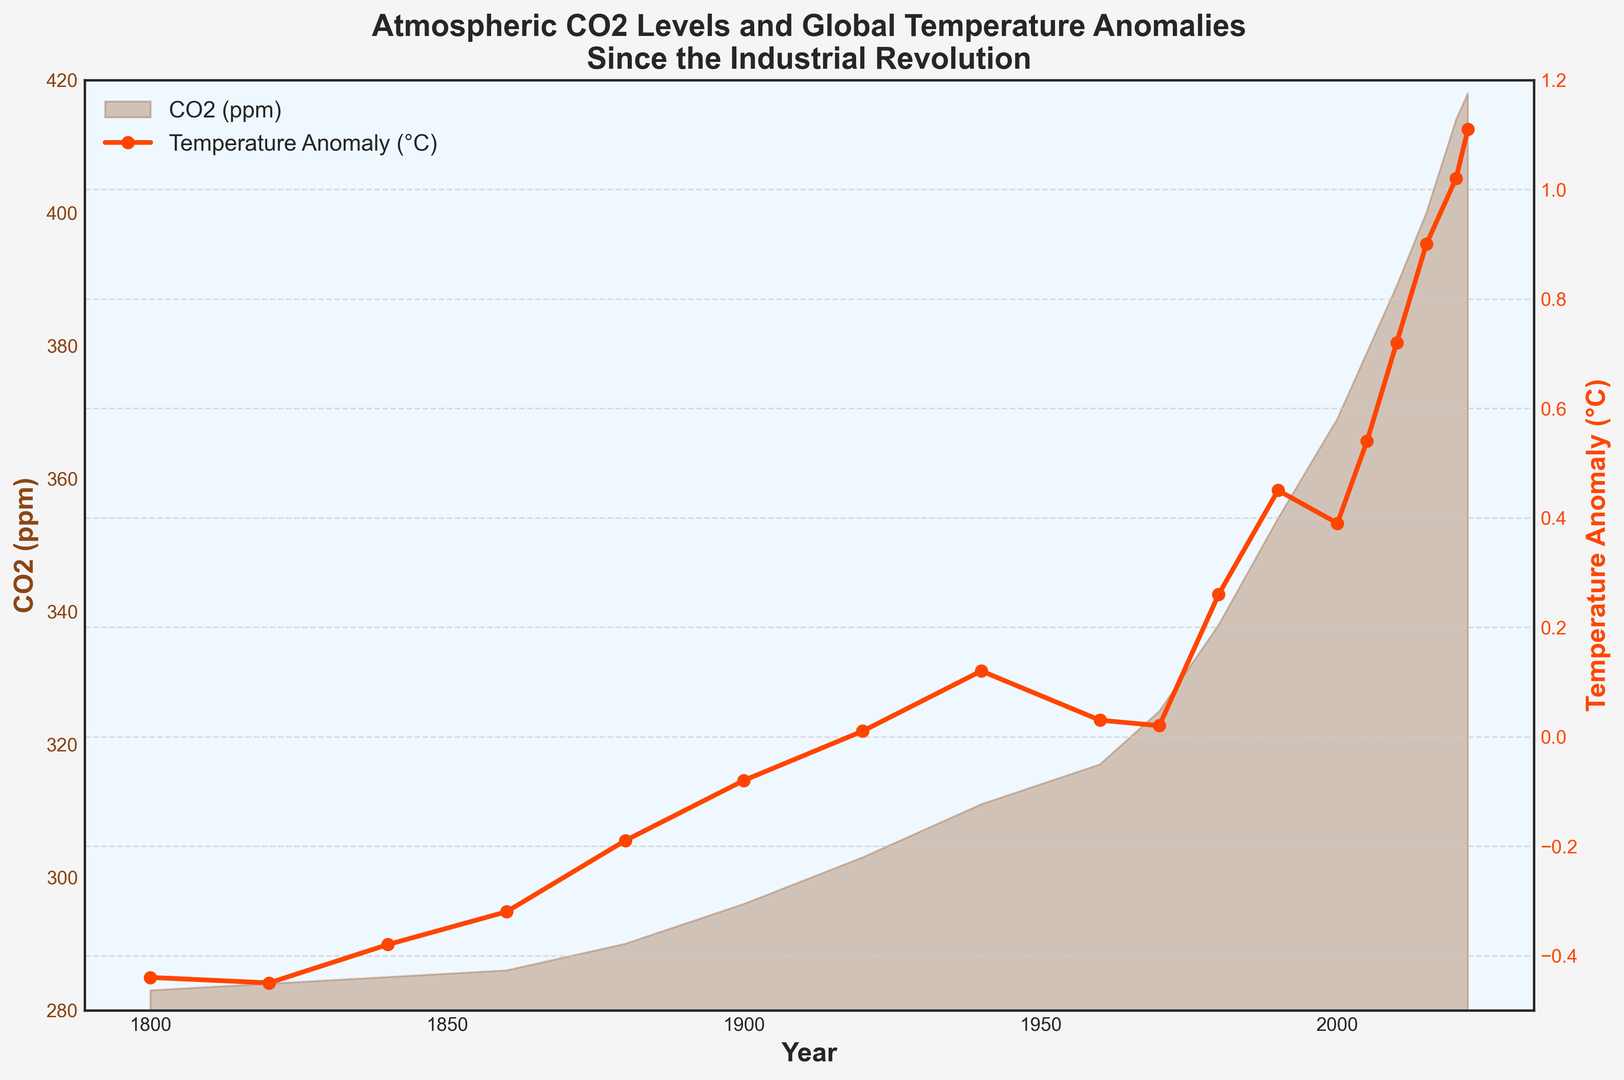Which year had the highest level of atmospheric CO2? The chart shows the CO2 (ppm) levels on the primary y-axis with CO2 levels increasing over time. Identify the peak value on this axis and locate which year it corresponds to in the x-axis.
Answer: 2022 What is the temperature anomaly in 1990? The chart plots temperature anomalies on the secondary y-axis with markers representing temperatures in each year. Locate the temperature anomaly for the year 1990.
Answer: 0.45°C How much did atmospheric CO2 increase from 1900 to 2000? On the primary y-axis, find the CO2 level corresponding to the years 1900 and 2000. Subtract the CO2 level in 1900 from the CO2 level in 2000 to find the increase.
Answer: 73 ppm During which period did the temperature anomaly show the most significant increase? Observe the slope of the temperature anomaly plot (secondary y-axis) over time and identify the period where the slope is steepest, indicating the largest increase.
Answer: 1980 to 2020 By how much did the temperature anomaly change between 1860 and 1960? Find and compare the temperature anomaly values for the years 1860 and 1960 from the secondary y-axis. Compute the difference between these values to determine the change.
Answer: 0.35°C Compare the CO2 levels in 1940 and 2020. Are the CO2 levels in 2020 greater than, less than, or equal to the levels in 1940? From the primary y-axis, identify CO2 levels for the years 1940 and 2020. Compare the two values to determine if one is greater than the other or if they are equal.
Answer: Greater than What is the visual trend of atmospheric CO2 levels after 1960? Look at the shape and direction of the filled area representing CO2 levels from 1960 onwards to determine the trend.
Answer: Increasing What is the average temperature anomaly from 2000 to 2020? Identify the temperature anomaly values for each year between 2000 and 2020 from the chart. Sum these values and divide by the number of years (2000, 2005, 2010, 2015, 2020, 2022) to find the average.
Answer: 0.61°C How does the temperature anomaly in 1880 compare to that in 1980? Locate the temperature anomaly values for 1880 and 1980 using the secondary y-axis and compare the two values.
Answer: 1980 is higher Which visual element represents atmospheric CO2 levels and how is it styled? Observing the figure, determine which visual element corresponds to CO2 levels and describe its style (e.g., color and filled area).
Answer: Brown filled area 